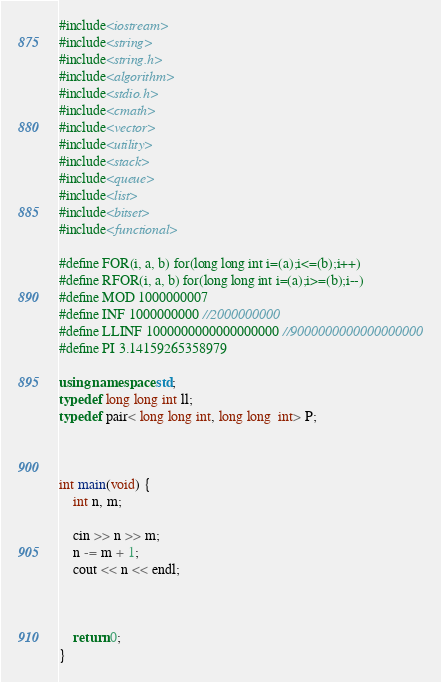Convert code to text. <code><loc_0><loc_0><loc_500><loc_500><_C++_>#include<iostream>
#include<string>
#include<string.h>
#include<algorithm>
#include<stdio.h>
#include<cmath>
#include<vector>
#include<utility>
#include<stack>
#include<queue>
#include<list>
#include<bitset>
#include<functional>

#define FOR(i, a, b) for(long long int i=(a);i<=(b);i++)
#define RFOR(i, a, b) for(long long int i=(a);i>=(b);i--)
#define MOD 1000000007
#define INF 1000000000 //2000000000
#define LLINF 1000000000000000000 //9000000000000000000
#define PI 3.14159265358979

using namespace std;
typedef long long int ll;
typedef pair< long long int, long long  int> P;



int main(void) {
	int n, m;

	cin >> n >> m;
	n -= m + 1;
	cout << n << endl;



	return 0;
}
</code> 